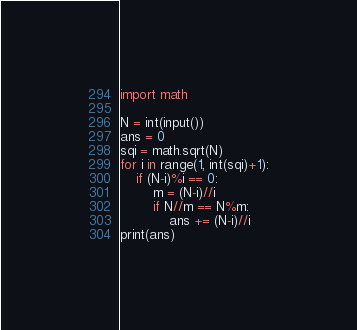<code> <loc_0><loc_0><loc_500><loc_500><_Python_>import math

N = int(input())
ans = 0
sqi = math.sqrt(N)
for i in range(1, int(sqi)+1):
    if (N-i)%i == 0:
        m = (N-i)//i
        if N//m == N%m:
        	ans += (N-i)//i
print(ans)</code> 